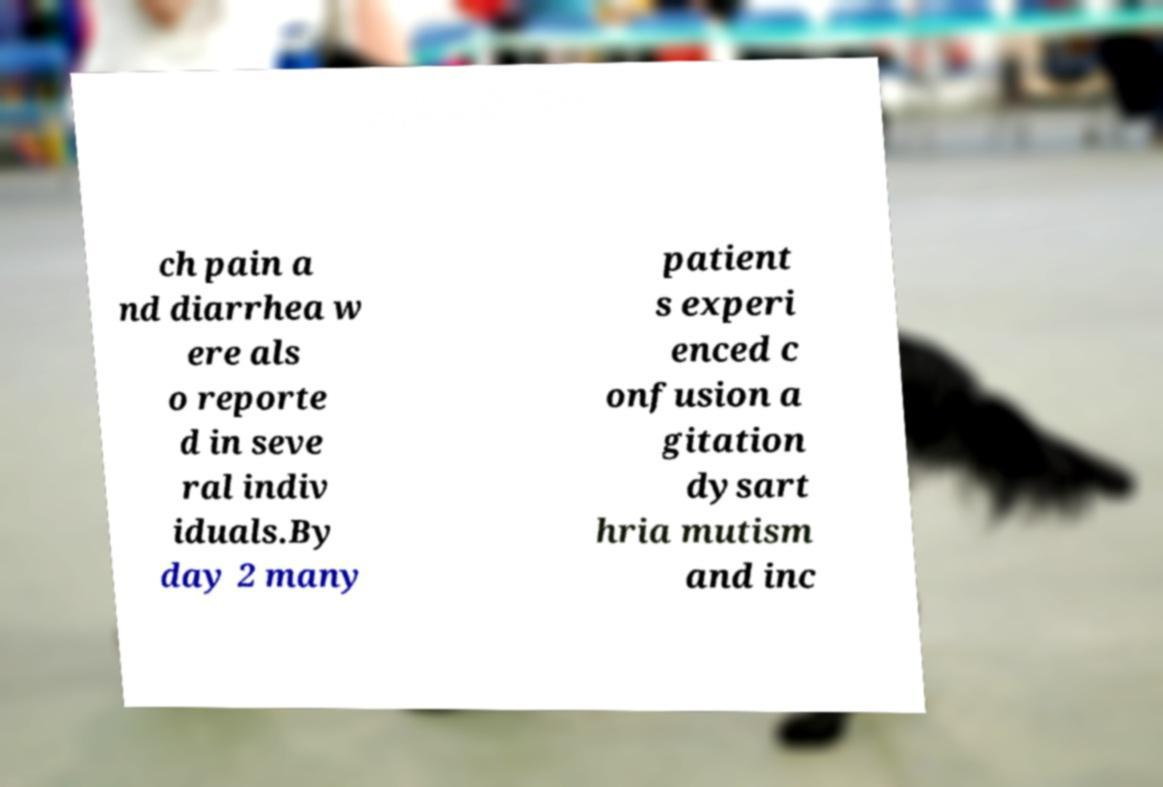Could you extract and type out the text from this image? ch pain a nd diarrhea w ere als o reporte d in seve ral indiv iduals.By day 2 many patient s experi enced c onfusion a gitation dysart hria mutism and inc 